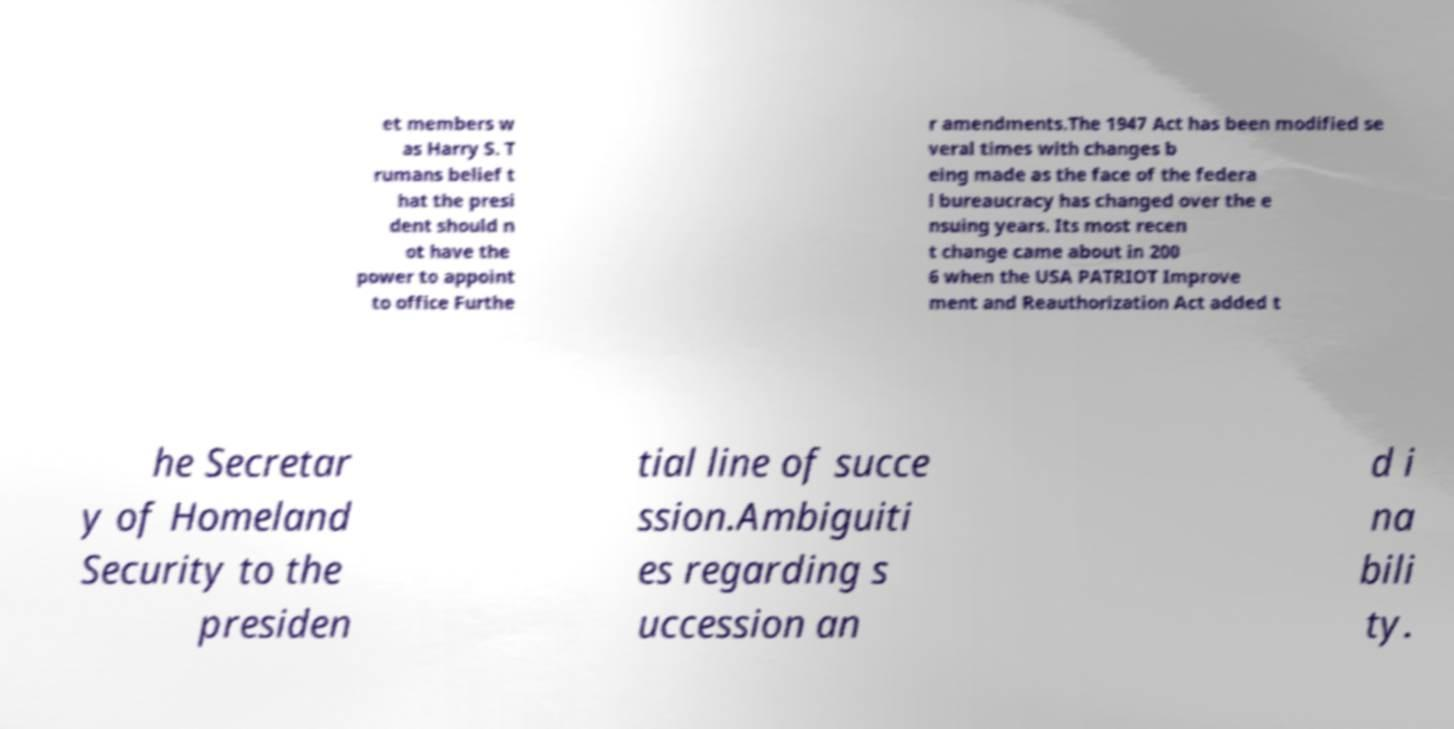Could you extract and type out the text from this image? et members w as Harry S. T rumans belief t hat the presi dent should n ot have the power to appoint to office Furthe r amendments.The 1947 Act has been modified se veral times with changes b eing made as the face of the federa l bureaucracy has changed over the e nsuing years. Its most recen t change came about in 200 6 when the USA PATRIOT Improve ment and Reauthorization Act added t he Secretar y of Homeland Security to the presiden tial line of succe ssion.Ambiguiti es regarding s uccession an d i na bili ty. 